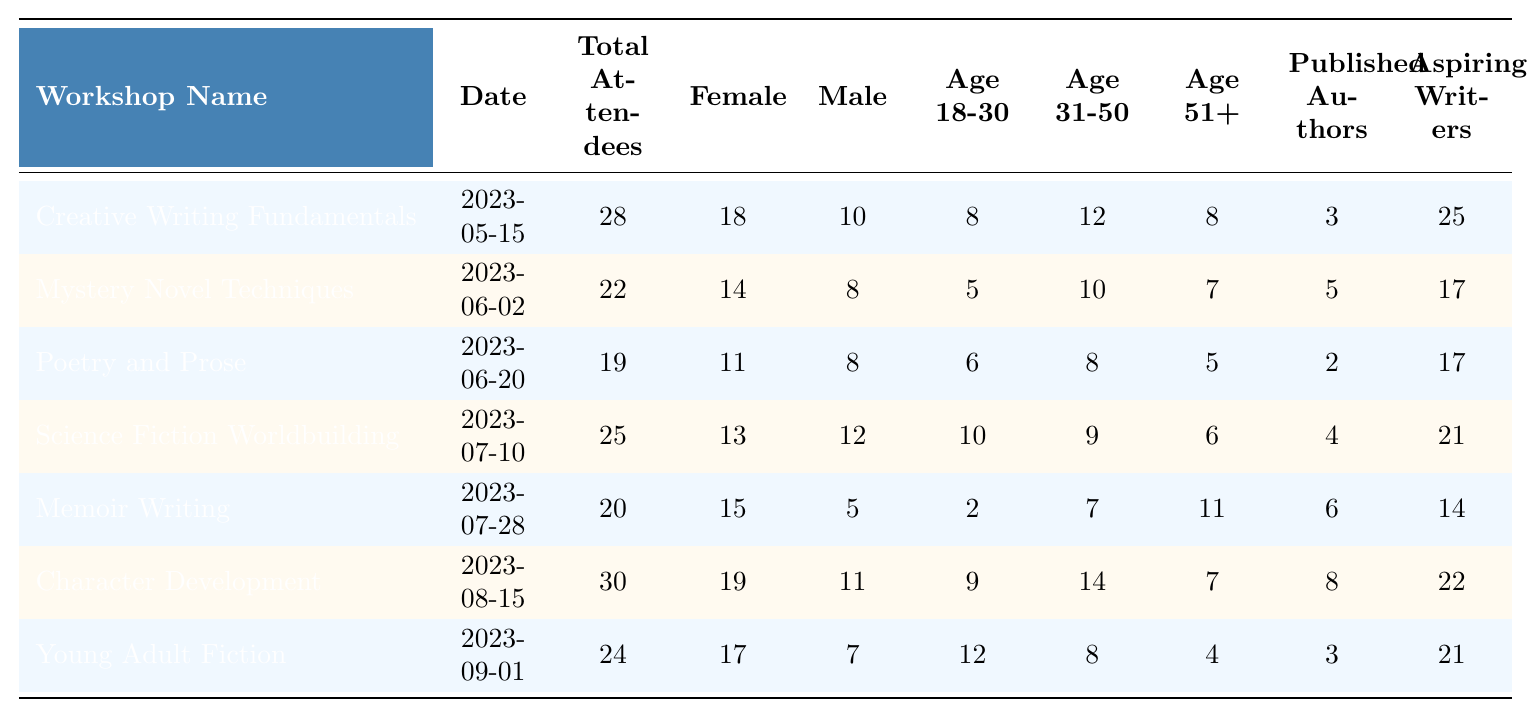What is the total number of attendees for the "Memoir Writing" workshop? The total number of attendees for the "Memoir Writing" workshop is listed directly in the table under the "Total Attendees" column for that specific workshop. The number is 20.
Answer: 20 Which workshop had the most female participants? To find the workshop with the most female participants, we compare the "Female Participants" column across all workshops. The maximum value is 19, which corresponds to the "Character Development" workshop.
Answer: Character Development How many male participants attended the "Young Adult Fiction" workshop? The number of male participants for the "Young Adult Fiction" workshop can be found in the "Male Participants" column for that workshop. This value is 7.
Answer: 7 What is the total number of aspiring writers across all workshops? To find the total number of aspiring writers, sum the values in the "Aspiring Writers" column. The values are 25 + 17 + 17 + 21 + 14 + 22 + 21 =  156.
Answer: 156 Is there a workshop that had no published authors? By checking the "Published Authors" column for each workshop, we can see that the "Poetry and Prose" workshop had 2 published authors, which means there is no workshop listed with zero published authors.
Answer: No What is the average number of attendees for the workshops held on or after June 1, 2023? The workshops held on or after June 1, 2023, are "Mystery Novel Techniques," "Poetry and Prose," "Science Fiction Worldbuilding," "Memoir Writing," "Character Development," and "Young Adult Fiction." The total number of attendees for these workshops is 22 + 19 + 25 + 20 + 30 + 24 = 140, dividing this by the number of workshops (6) gives us an average of 140/6 ≈ 23.33.
Answer: 23.33 Which demographic group had the highest participation among attendees aged 31-50? To determine which demographic group had the most participants aged 31-50, we find the maximum value in the "Age 31-50" column. The maximum number is 14, which is from the "Character Development" workshop.
Answer: Character Development How many attendees were aged 51 and above for the "Science Fiction Worldbuilding" workshop? The number of attendees aged 51 and above for the "Science Fiction Worldbuilding" workshop is found in the "Age 51+" column for that workshop. It shows that there were 6 participants aged 51 and above.
Answer: 6 What percentage of total attendees were female in the "Creative Writing Fundamentals" workshop? In the "Creative Writing Fundamentals" workshop, there were 28 total attendees and 18 were female. To find the percentage, calculate (18/28) * 100, which equals approximately 64.29%.
Answer: 64.29% How does the number of published authors in "Character Development" compare to that in "Memoir Writing"? The "Character Development" workshop had 8 published authors, while the "Memoir Writing" workshop had 6. Therefore, "Character Development" had 2 more published authors than "Memoir Writing."
Answer: 2 more 